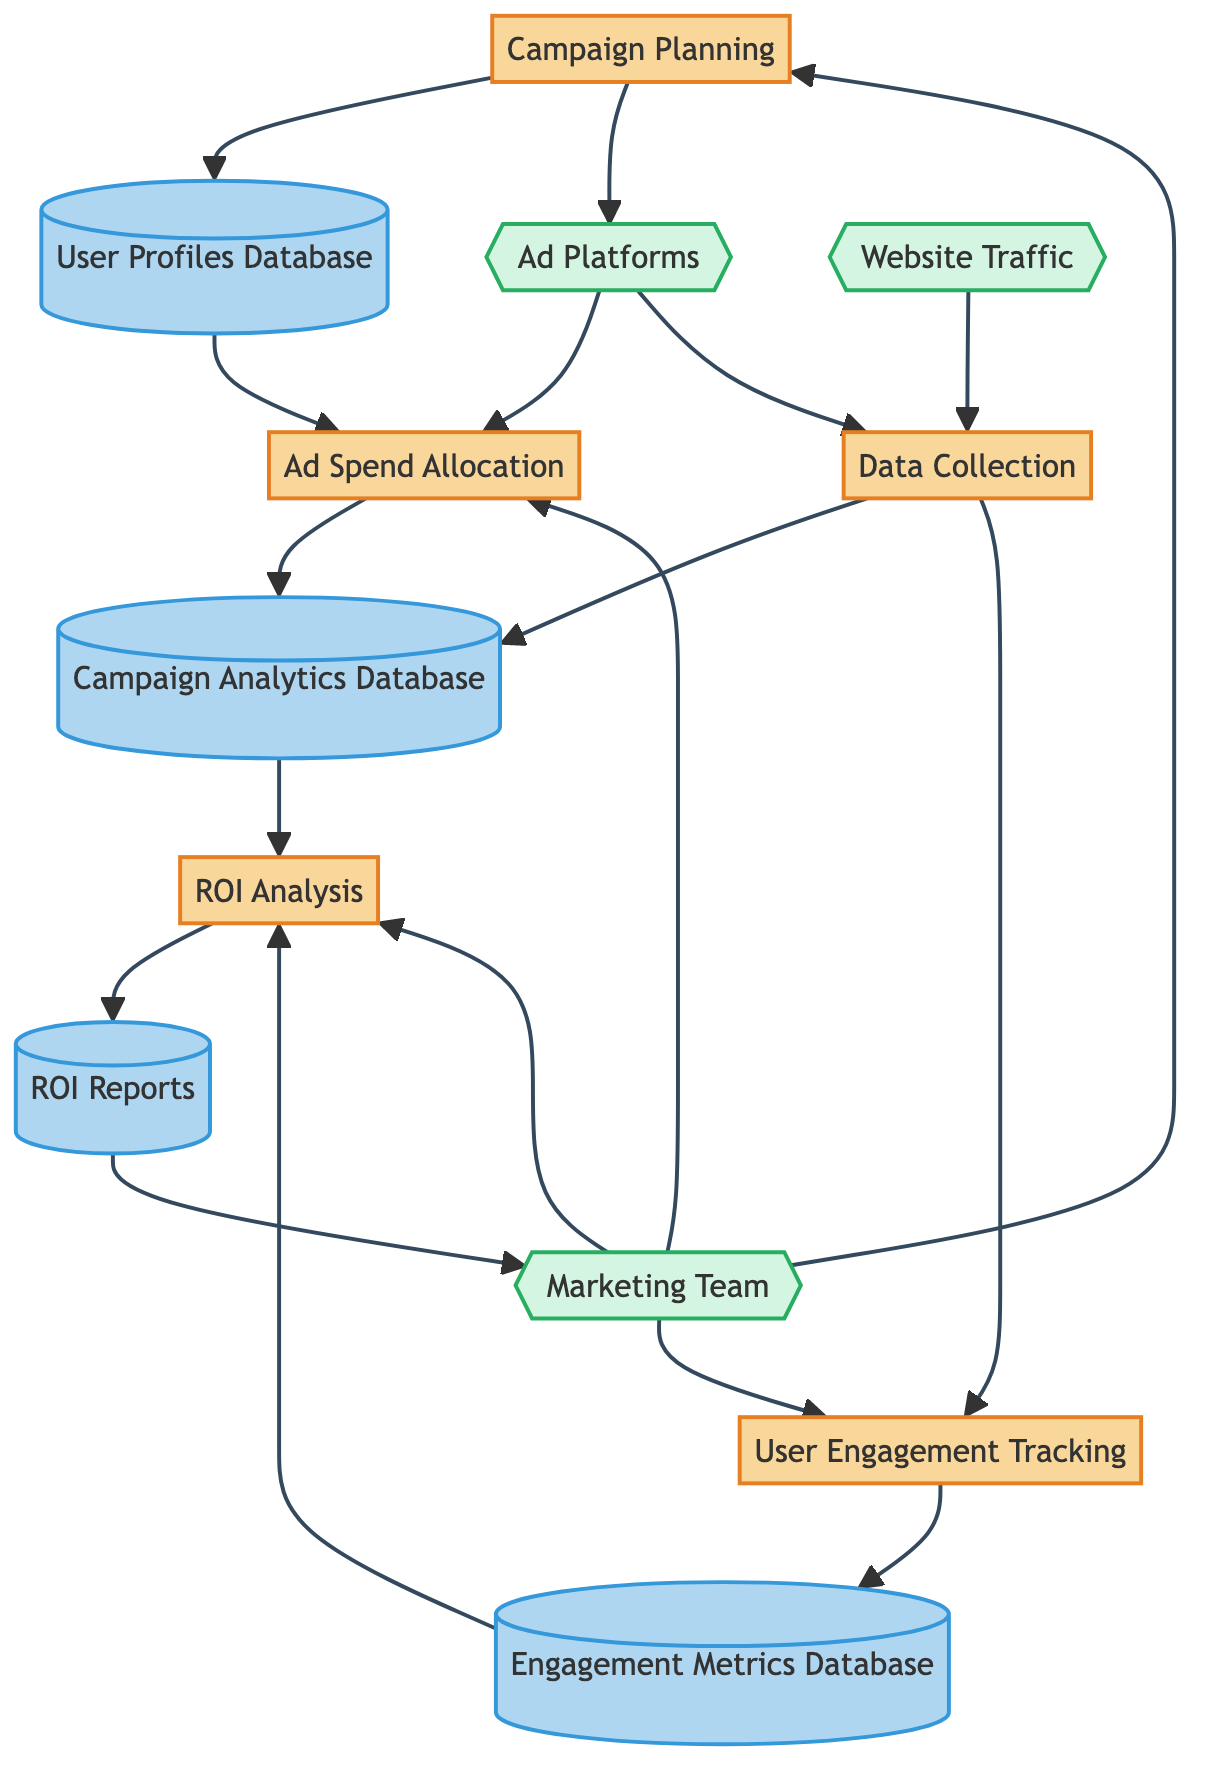How many processes are in the diagram? The diagram includes the following processes: Campaign Planning, Ad Spend Allocation, Data Collection, User Engagement Tracking, and ROI Analysis. Counting these shows there are a total of 5 processes.
Answer: 5 What is the role of the Marketing Team in this diagram? The Marketing Team is an external entity that interacts with multiple processes: they initiate the Campaign Planning process, manage the Ad Spend Allocation, oversee User Engagement Tracking, and are involved in the ROI Analysis. Thus, their role is central to the execution and management of the campaign.
Answer: Execution and management Which data store is connected to the Data Collection process? The Data Collection process connects to two data stores: Campaign Analytics Database and Engagement Metrics Database. Therefore, both stores are linked directly to the Data Collection process.
Answer: Campaign Analytics Database and Engagement Metrics Database How many external entities are present in the diagram? There are three external entities in the diagram: Ad Platforms, Website Traffic, and the Marketing Team. Counting these gives a total of 3 external entities present.
Answer: 3 What data flows from User Profiles Database to Ad Spend Allocation? The flow from User Profiles Database to Ad Spend Allocation consists of targeting information used to inform the budget distribution across different platforms. This highlights how user data influences ad spend decisions.
Answer: Targeting information What is generated after the ROI Analysis process? After the ROI Analysis process is completed, ROI Reports are generated, showcasing the profitability and success metrics of the marketing campaigns. This is crucial for understanding the effectiveness of the spent budget.
Answer: ROI Reports What is the main purpose of the Campaign Analytics Database? The Campaign Analytics Database is designed to store data on ad performance, user engagement, and conversion metrics. This repository is essential for analyzing and optimizing the campaign's effectiveness.
Answer: Store data on ad performance How does the User Engagement Tracking process relate to the Engagement Metrics Database? User Engagement Tracking collects data on user interactions and feeds this information into the Engagement Metrics Database, thereby providing a comprehensive view of user engagement with the campaign. This flow highlights the importance of tracking user behavior in understanding engagement levels.
Answer: Collects user interaction data What is the connection between Ad Platforms and Ad Spend Allocation? Ad Platforms feed into the Ad Spend Allocation process as they are the vehicles through which ads are placed. This connection indicates that budget distribution directly depends on the platforms selected for the campaign.
Answer: Budget distribution 